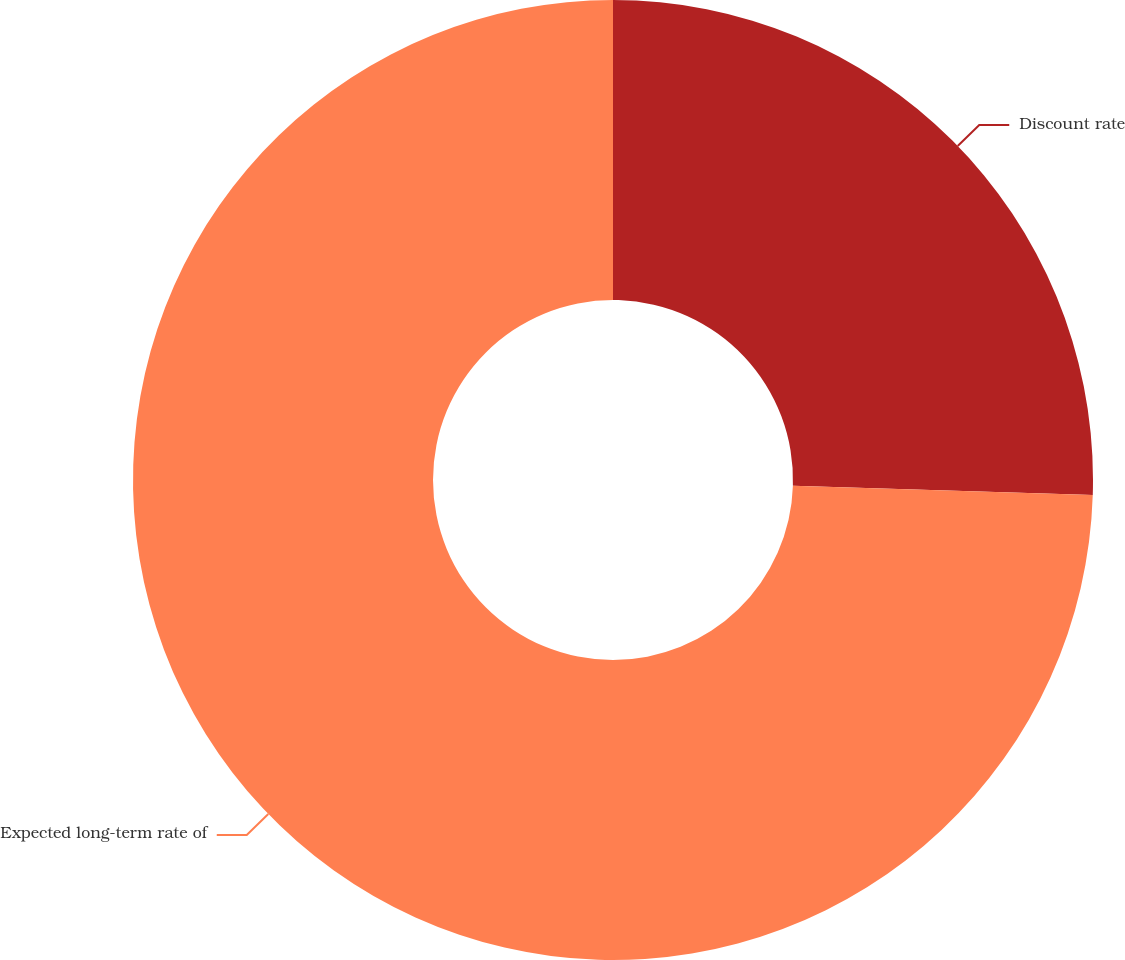<chart> <loc_0><loc_0><loc_500><loc_500><pie_chart><fcel>Discount rate<fcel>Expected long-term rate of<nl><fcel>25.5%<fcel>74.5%<nl></chart> 